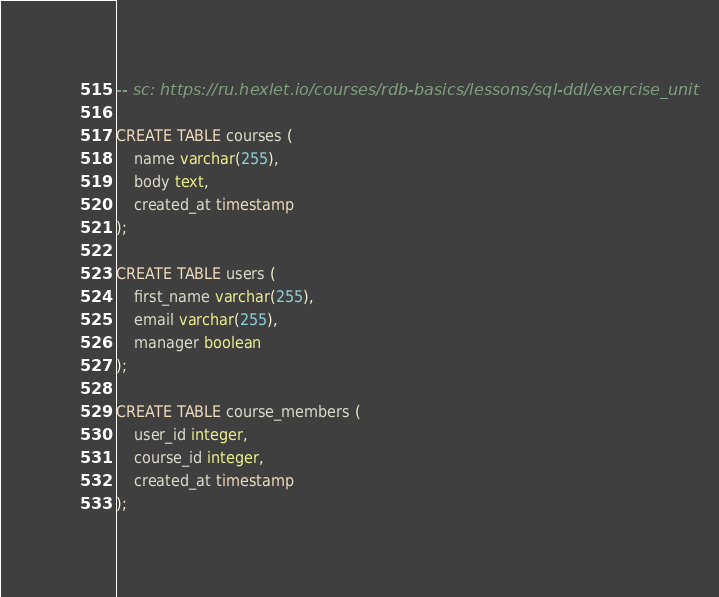<code> <loc_0><loc_0><loc_500><loc_500><_SQL_>-- sc: https://ru.hexlet.io/courses/rdb-basics/lessons/sql-ddl/exercise_unit

CREATE TABLE courses (
    name varchar(255),
    body text,
    created_at timestamp
);

CREATE TABLE users (
    first_name varchar(255),
    email varchar(255),
    manager boolean
);

CREATE TABLE course_members (
    user_id integer,
    course_id integer,
    created_at timestamp
);</code> 